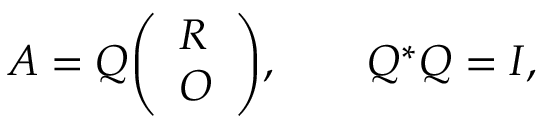Convert formula to latex. <formula><loc_0><loc_0><loc_500><loc_500>A = Q { \left ( \begin{array} { l } { R } \\ { O } \end{array} \right ) } , \quad Q ^ { * } Q = I ,</formula> 